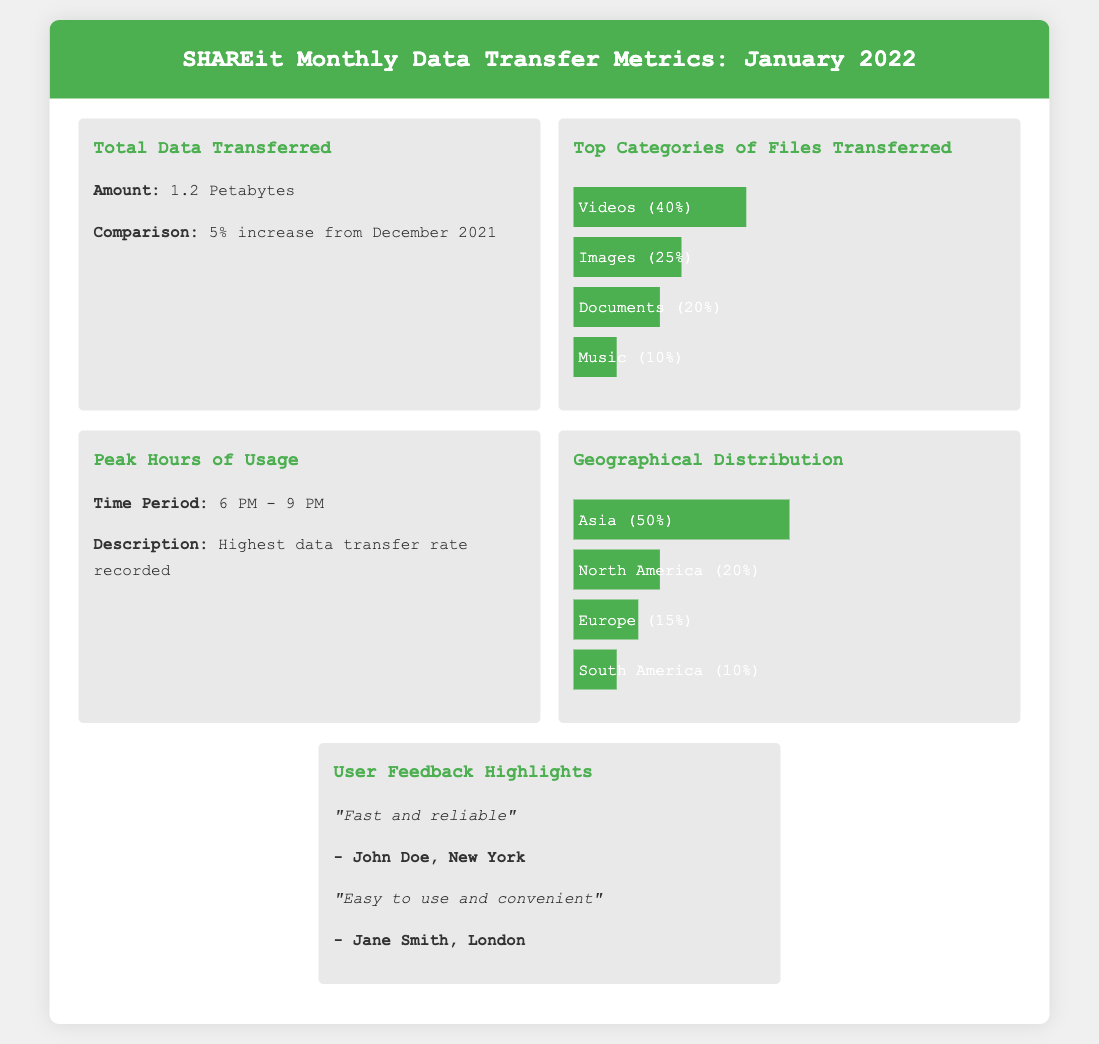What was the total data transferred in January 2022? The total data transferred is explicitly stated in the document as 1.2 Petabytes.
Answer: 1.2 Petabytes What was the percentage increase in data transferred compared to December 2021? The document states that there was a 5% increase in data transferred from December 2021.
Answer: 5% What category of files had the highest transfer percentage? The document shows that Videos had the highest transfer percentage at 40%.
Answer: Videos (40%) During what time period were the peak hours of usage? The document specifies the peak hours of usage as 6 PM - 9 PM.
Answer: 6 PM - 9 PM Which continent accounted for the highest percentage of data transfer? The geographical distribution shows Asia accounted for 50% of data transfer, the highest among the listed continents.
Answer: Asia (50%) How many user feedback highlights are presented in the document? The document contains two user feedback highlights.
Answer: Two What was the percentage of file transfers for Music? The document indicates that Music accounted for 10% of file transfers.
Answer: 10% What does the user feedback emphasize about the SHAREit service? The feedback emphasizes that the service is fast and reliable, and easy to use and convenient.
Answer: Fast and reliable What percentage of data was transferred in North America? According to the geographical distribution, North America accounted for 20% of data transfer.
Answer: 20% 